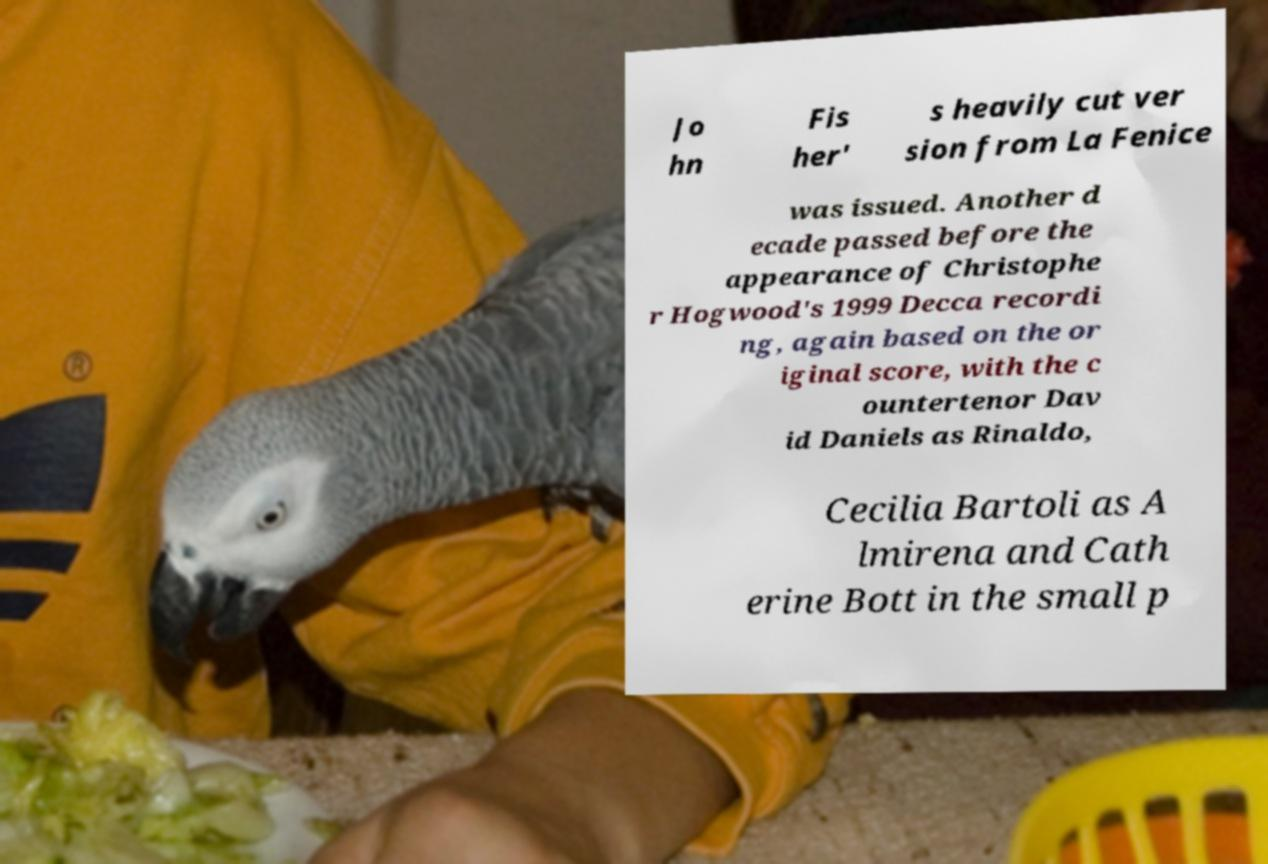Please identify and transcribe the text found in this image. Jo hn Fis her' s heavily cut ver sion from La Fenice was issued. Another d ecade passed before the appearance of Christophe r Hogwood's 1999 Decca recordi ng, again based on the or iginal score, with the c ountertenor Dav id Daniels as Rinaldo, Cecilia Bartoli as A lmirena and Cath erine Bott in the small p 